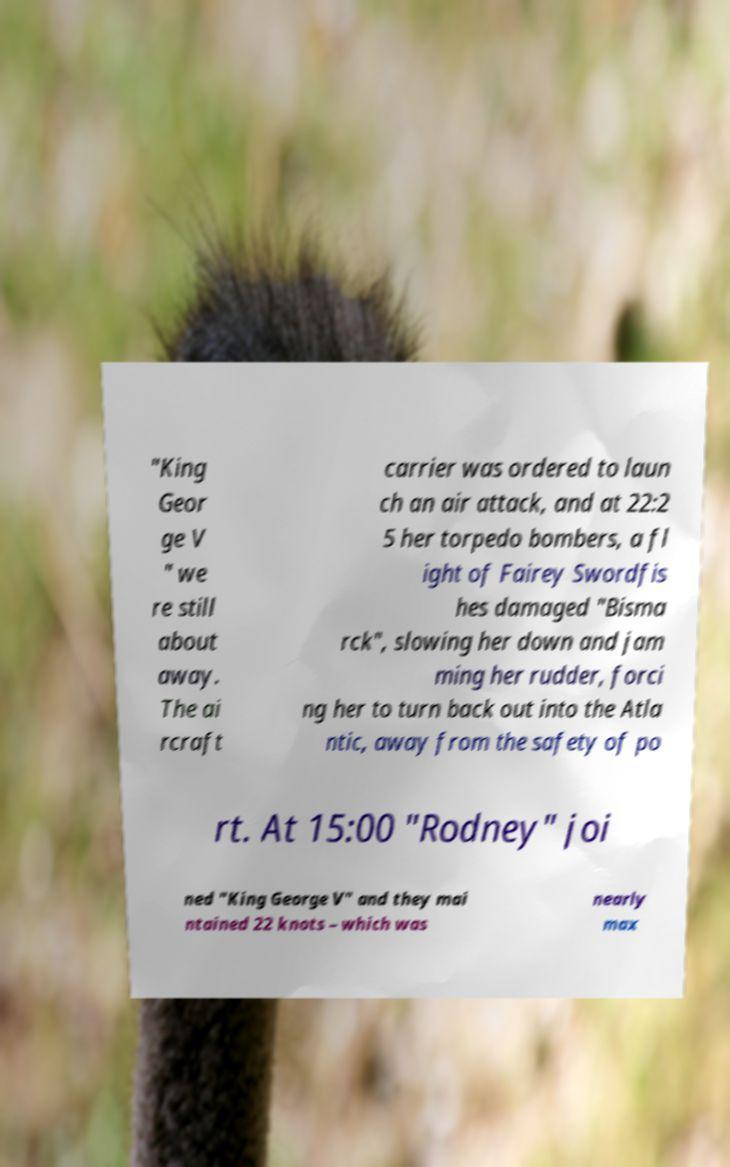What messages or text are displayed in this image? I need them in a readable, typed format. "King Geor ge V " we re still about away. The ai rcraft carrier was ordered to laun ch an air attack, and at 22:2 5 her torpedo bombers, a fl ight of Fairey Swordfis hes damaged "Bisma rck", slowing her down and jam ming her rudder, forci ng her to turn back out into the Atla ntic, away from the safety of po rt. At 15:00 "Rodney" joi ned "King George V" and they mai ntained 22 knots – which was nearly max 